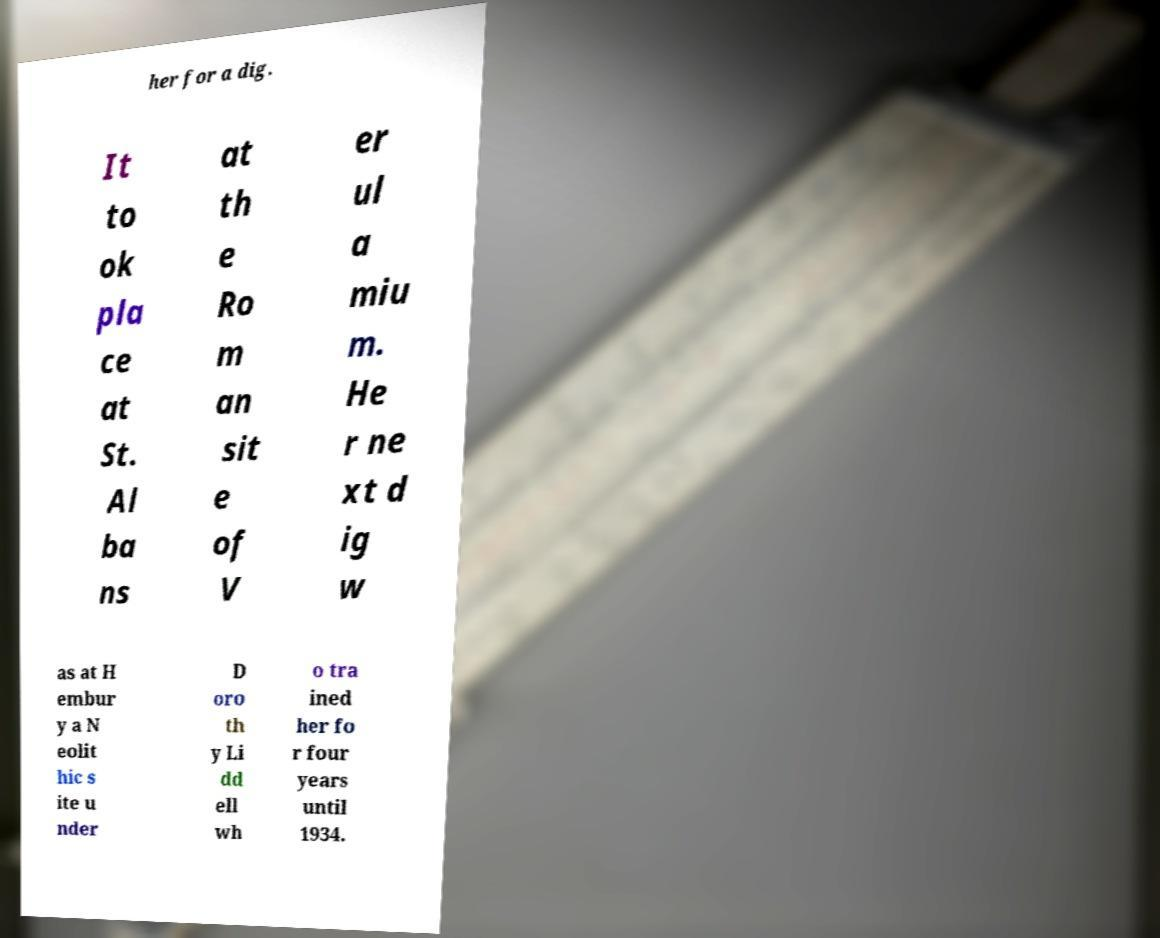Please identify and transcribe the text found in this image. her for a dig. It to ok pla ce at St. Al ba ns at th e Ro m an sit e of V er ul a miu m. He r ne xt d ig w as at H embur y a N eolit hic s ite u nder D oro th y Li dd ell wh o tra ined her fo r four years until 1934. 